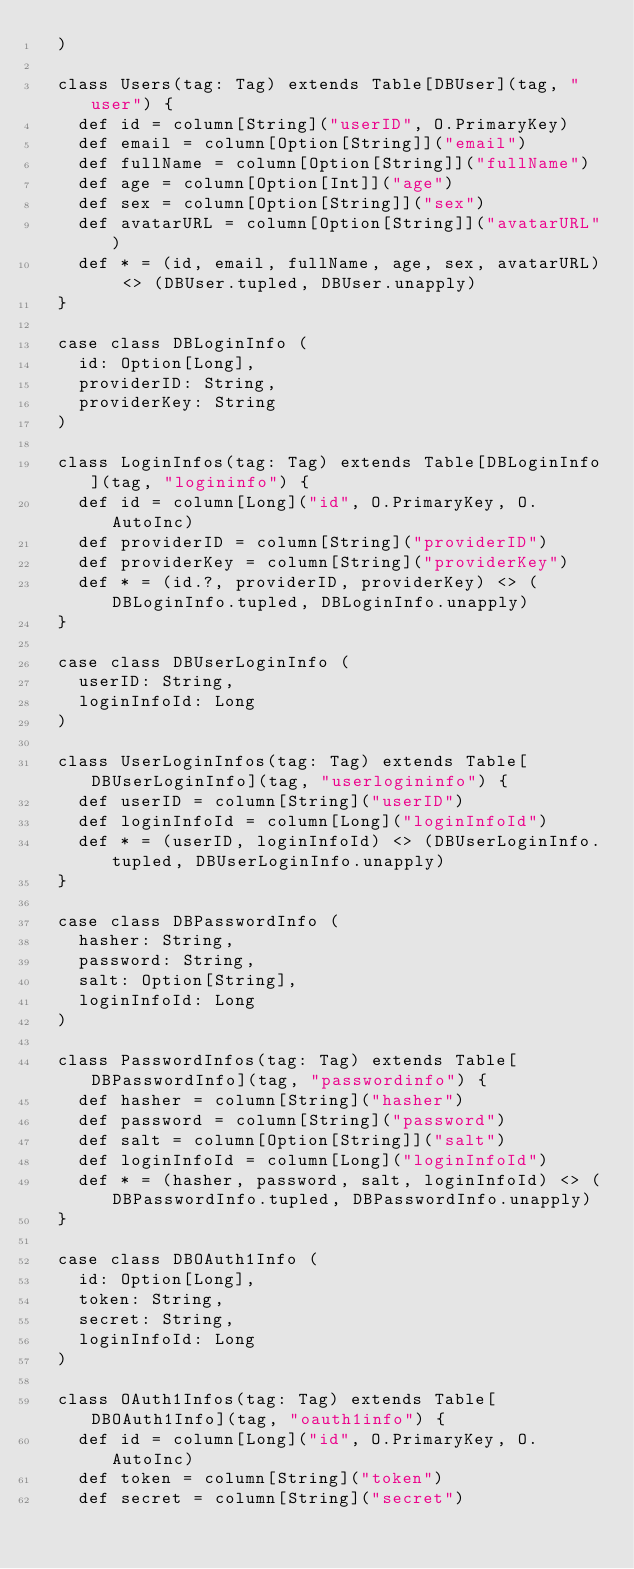Convert code to text. <code><loc_0><loc_0><loc_500><loc_500><_Scala_>  )

  class Users(tag: Tag) extends Table[DBUser](tag, "user") {
    def id = column[String]("userID", O.PrimaryKey)
    def email = column[Option[String]]("email")
    def fullName = column[Option[String]]("fullName")
    def age = column[Option[Int]]("age")
    def sex = column[Option[String]]("sex")
    def avatarURL = column[Option[String]]("avatarURL")
    def * = (id, email, fullName, age, sex, avatarURL) <> (DBUser.tupled, DBUser.unapply)
  }

  case class DBLoginInfo (
    id: Option[Long],
    providerID: String,
    providerKey: String
  )

  class LoginInfos(tag: Tag) extends Table[DBLoginInfo](tag, "logininfo") {
    def id = column[Long]("id", O.PrimaryKey, O.AutoInc)
    def providerID = column[String]("providerID")
    def providerKey = column[String]("providerKey")
    def * = (id.?, providerID, providerKey) <> (DBLoginInfo.tupled, DBLoginInfo.unapply)
  }

  case class DBUserLoginInfo (
    userID: String,
    loginInfoId: Long
  )

  class UserLoginInfos(tag: Tag) extends Table[DBUserLoginInfo](tag, "userlogininfo") {
    def userID = column[String]("userID")
    def loginInfoId = column[Long]("loginInfoId")
    def * = (userID, loginInfoId) <> (DBUserLoginInfo.tupled, DBUserLoginInfo.unapply)
  }

  case class DBPasswordInfo (
    hasher: String,
    password: String,
    salt: Option[String],
    loginInfoId: Long
  )

  class PasswordInfos(tag: Tag) extends Table[DBPasswordInfo](tag, "passwordinfo") {
    def hasher = column[String]("hasher")
    def password = column[String]("password")
    def salt = column[Option[String]]("salt")
    def loginInfoId = column[Long]("loginInfoId")
    def * = (hasher, password, salt, loginInfoId) <> (DBPasswordInfo.tupled, DBPasswordInfo.unapply)
  }

  case class DBOAuth1Info (
    id: Option[Long],
    token: String,
    secret: String,
    loginInfoId: Long
  )

  class OAuth1Infos(tag: Tag) extends Table[DBOAuth1Info](tag, "oauth1info") {
    def id = column[Long]("id", O.PrimaryKey, O.AutoInc)
    def token = column[String]("token")
    def secret = column[String]("secret")</code> 